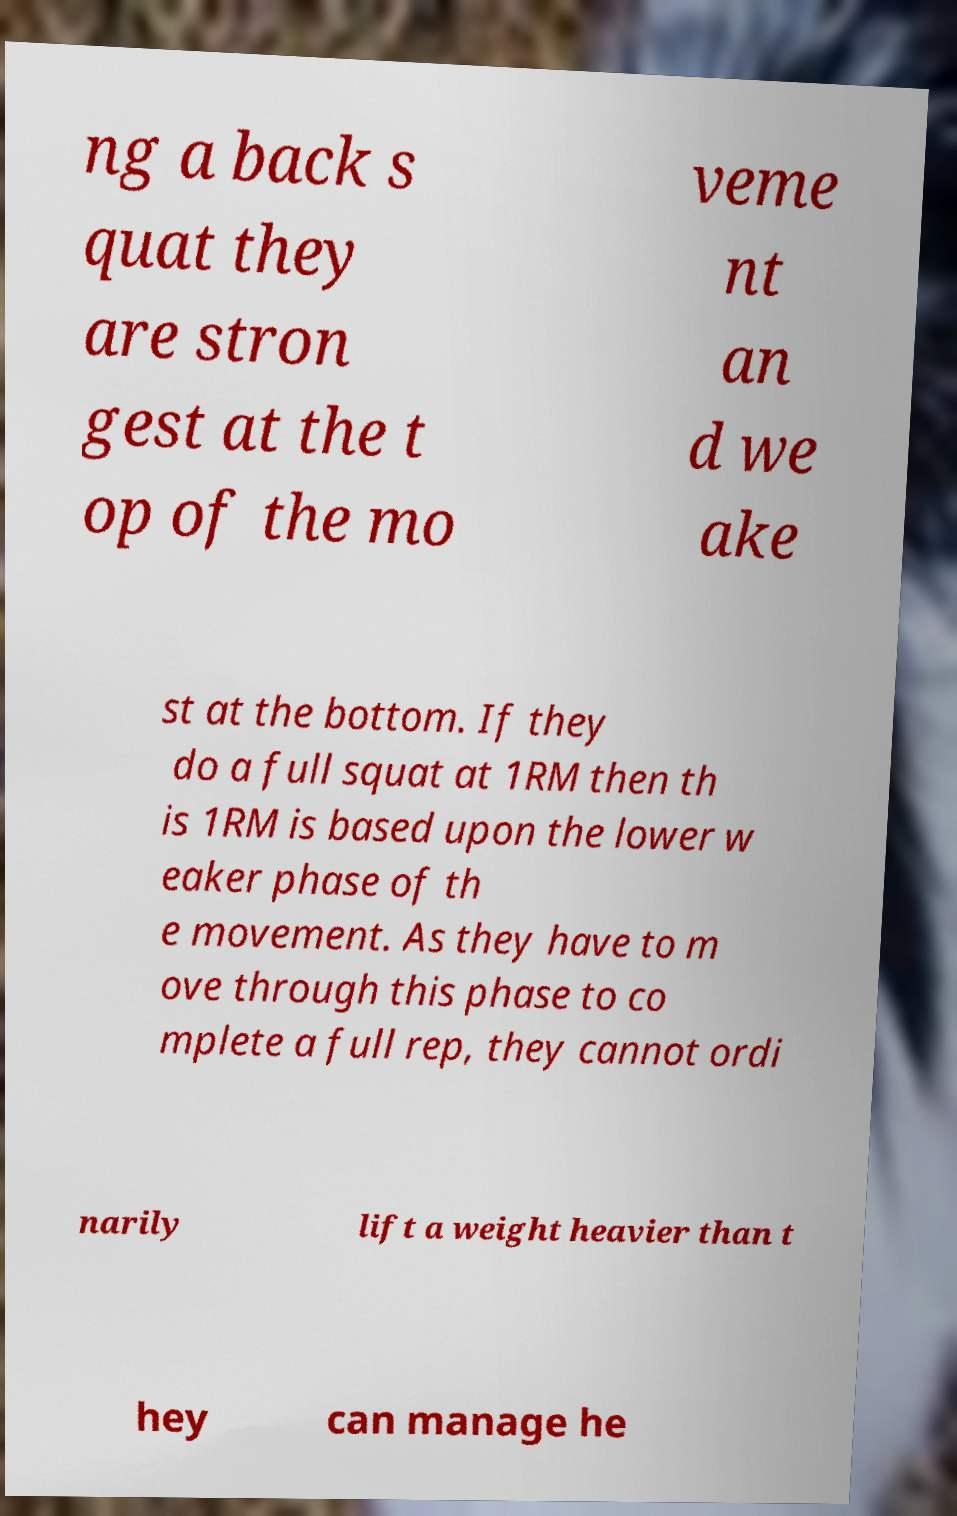What messages or text are displayed in this image? I need them in a readable, typed format. ng a back s quat they are stron gest at the t op of the mo veme nt an d we ake st at the bottom. If they do a full squat at 1RM then th is 1RM is based upon the lower w eaker phase of th e movement. As they have to m ove through this phase to co mplete a full rep, they cannot ordi narily lift a weight heavier than t hey can manage he 